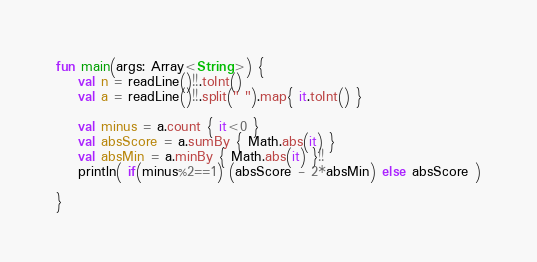Convert code to text. <code><loc_0><loc_0><loc_500><loc_500><_Kotlin_>fun main(args: Array<String>) {
    val n = readLine()!!.toInt()
    val a = readLine()!!.split(" ").map{ it.toInt() }

    val minus = a.count { it<0 }
    val absScore = a.sumBy { Math.abs(it) }
    val absMin = a.minBy { Math.abs(it) }!!
    println( if(minus%2==1) (absScore - 2*absMin) else absScore )

}</code> 